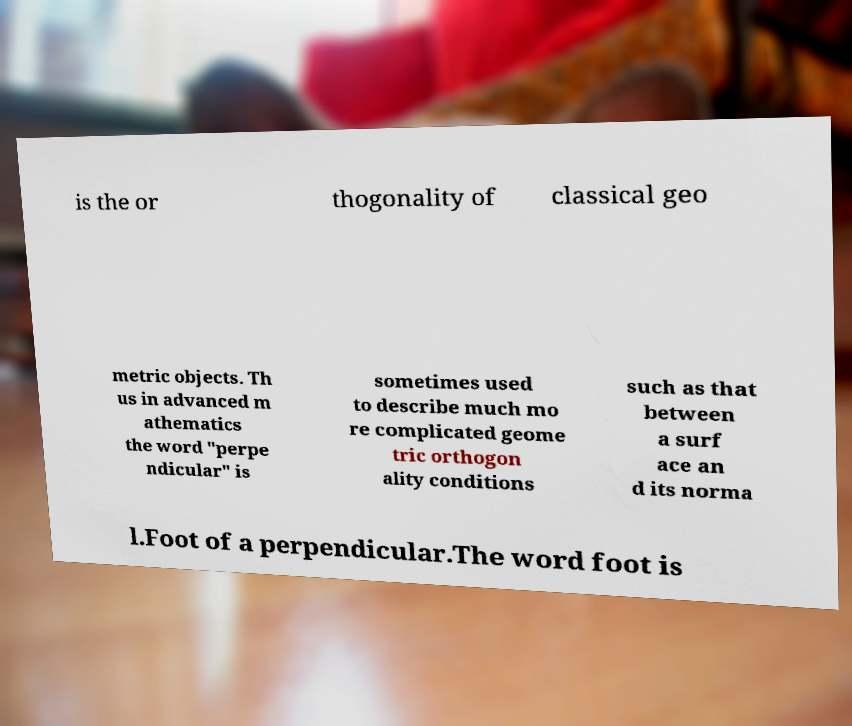I need the written content from this picture converted into text. Can you do that? is the or thogonality of classical geo metric objects. Th us in advanced m athematics the word "perpe ndicular" is sometimes used to describe much mo re complicated geome tric orthogon ality conditions such as that between a surf ace an d its norma l.Foot of a perpendicular.The word foot is 